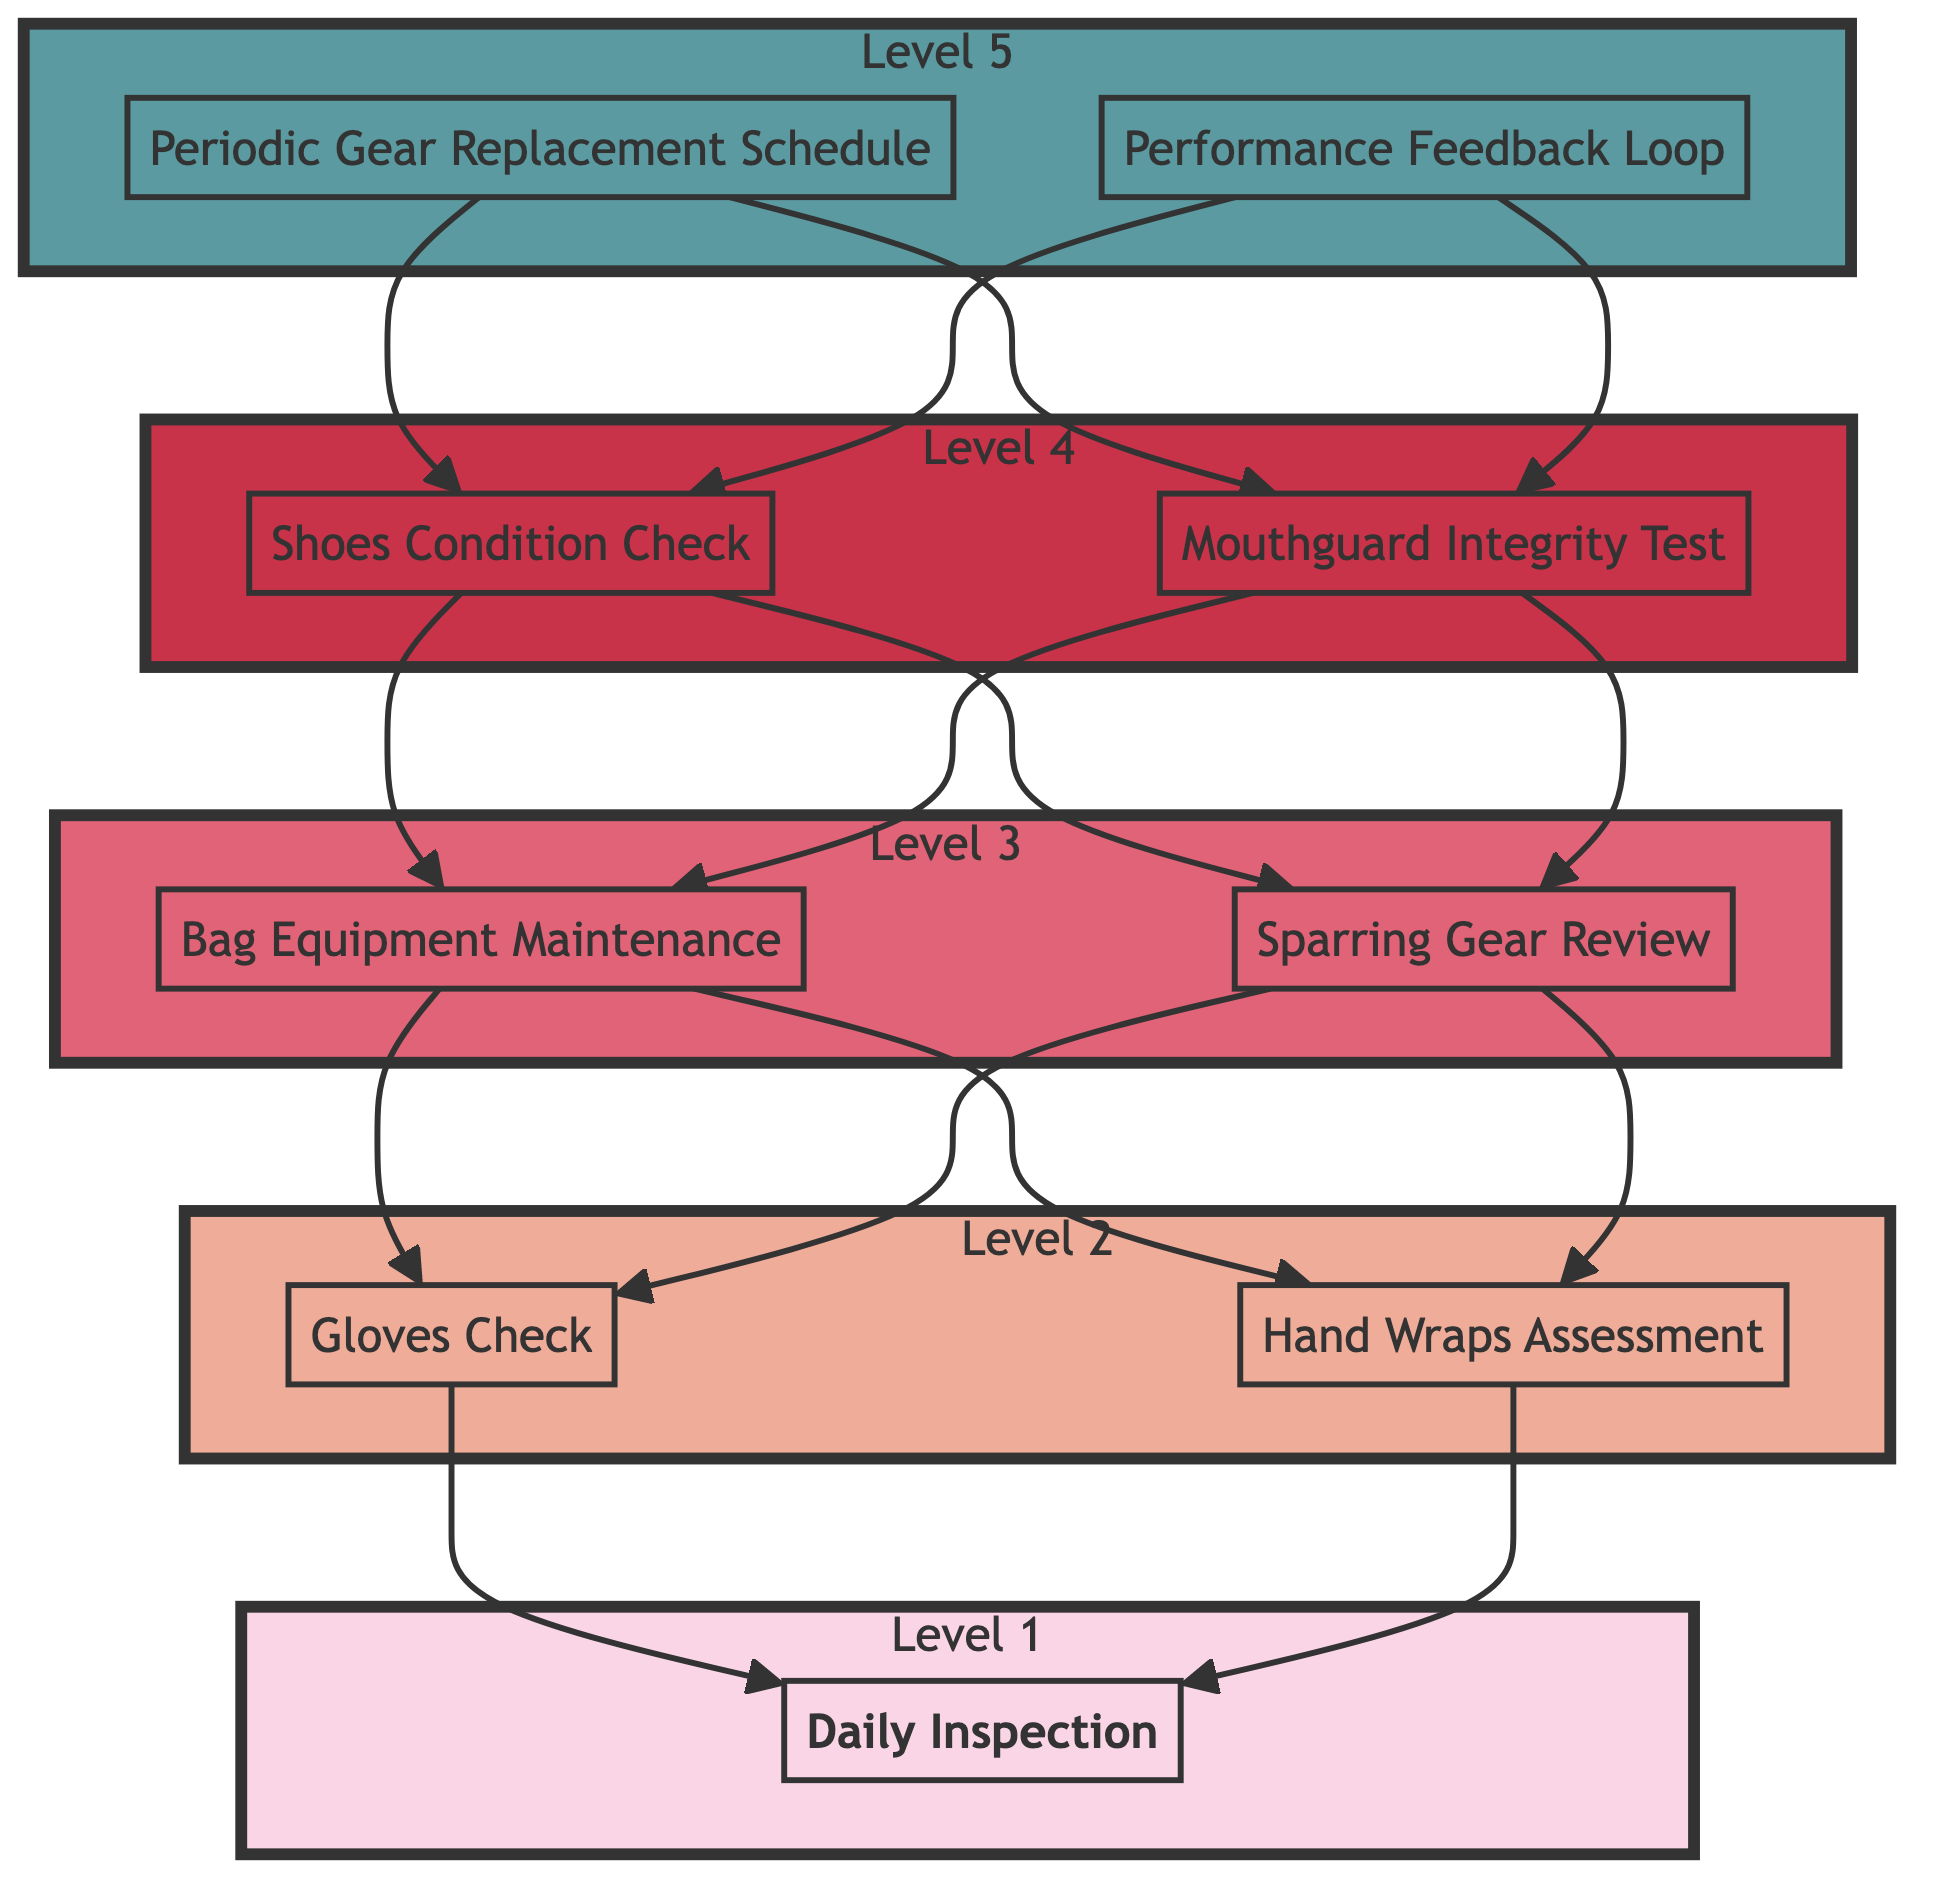What is the highest level in the diagram? The highest level in the diagram is Level 5, which includes the nodes "Periodic Gear Replacement Schedule" and "Performance Feedback Loop." It is at the top of the flow, reflecting its importance in the maintenance schedule.
Answer: Level 5 How many nodes are in Level 2? In Level 2, there are two nodes: "Gloves Check" and "Hand Wraps Assessment." Counting these nodes gives us the total number of nodes in that specific level.
Answer: 2 Which node directly leads to the "Daily Inspection"? The node "Gloves Check" and "Hand Wraps Assessment" lead to "Daily Inspection." In order to answer this, we trace the flow from both nodes through the diagram to identify which one directly promotes "Daily Inspection."
Answer: Gloves Check and Hand Wraps Assessment What is inspected in the "Shoes Condition Check"? In the "Shoes Condition Check," boxing shoes are inspected for sole wear, specifically identifying whether the soles are slick. This answer can be derived directly from the description of the node.
Answer: Boxing shoes for sole wear Which node requires checking the mouthguard? The node that requires checking the mouthguard is "Mouthguard Integrity Test." This can be determined by directly referencing the node where the specifics of mouthguard checks are mentioned.
Answer: Mouthguard Integrity Test Are both "Bag Equipment Maintenance" and "Sparring Gear Review" at the same level? Yes, both "Bag Equipment Maintenance" and "Sparring Gear Review" are at Level 3. This can be verified by looking at the structure of the diagram and noting the levels assigned to each node.
Answer: Yes What is the relationship between "Periodic Gear Replacement Schedule" and "Shoes Condition Check"? The "Periodic Gear Replacement Schedule" points towards both "Shoes Condition Check" and "Mouthguard Integrity Test," indicating it influences these maintenance checks. This relationship can be traced through the direction of the arrows in the diagram.
Answer: Points towards How many layers are there in the flowchart? The flowchart has five layers ranging from Level 1 to Level 5. This can be counted by simply identifying the number of discrete levels represented in the diagram.
Answer: 5 What action is taken if the gloves show signs of damage? If the gloves show signs of damage, the recommendation would likely be to inspect the padding and stitching for integrity. This can be inferred from the corresponding description listed under the "Gloves Check" node.
Answer: Inspect padding and stitching for integrity 